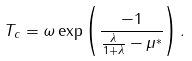Convert formula to latex. <formula><loc_0><loc_0><loc_500><loc_500>T _ { c } = \omega \exp \left ( \frac { - 1 } { \frac { \lambda } { 1 + \lambda } - \mu ^ { \ast } } \right ) .</formula> 